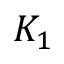<formula> <loc_0><loc_0><loc_500><loc_500>K _ { 1 }</formula> 